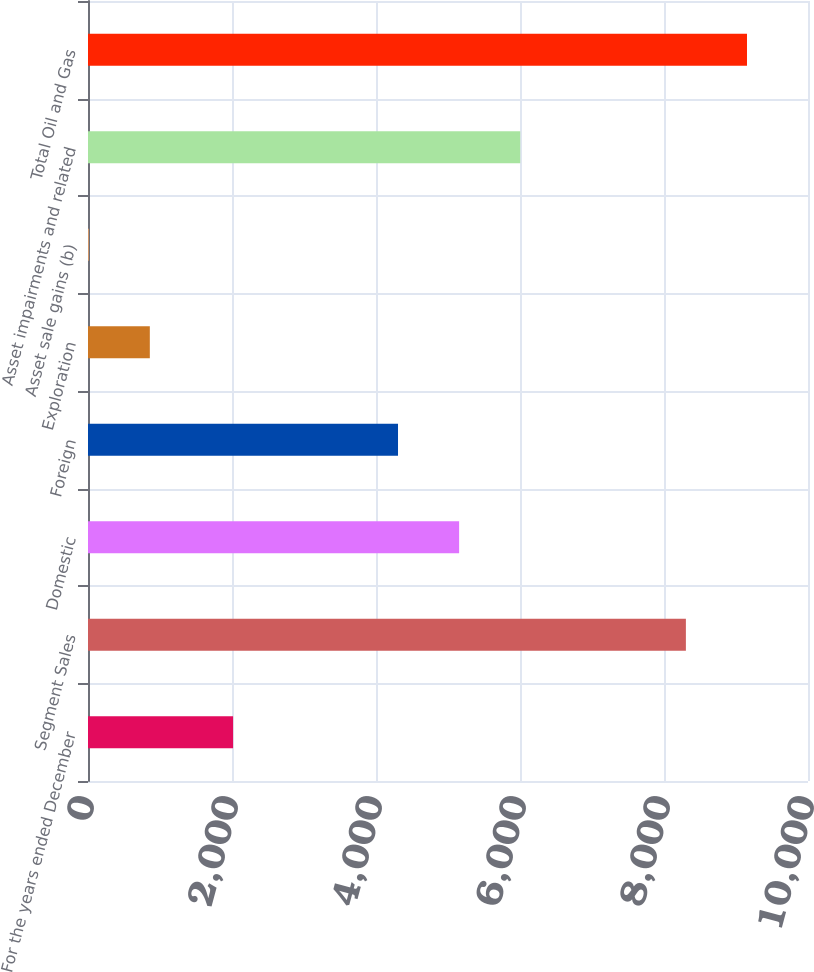<chart> <loc_0><loc_0><loc_500><loc_500><bar_chart><fcel>For the years ended December<fcel>Segment Sales<fcel>Domestic<fcel>Foreign<fcel>Exploration<fcel>Asset sale gains (b)<fcel>Asset impairments and related<fcel>Total Oil and Gas<nl><fcel>2015<fcel>8304<fcel>5154.4<fcel>4305.7<fcel>858.7<fcel>10<fcel>6003.1<fcel>9152.7<nl></chart> 